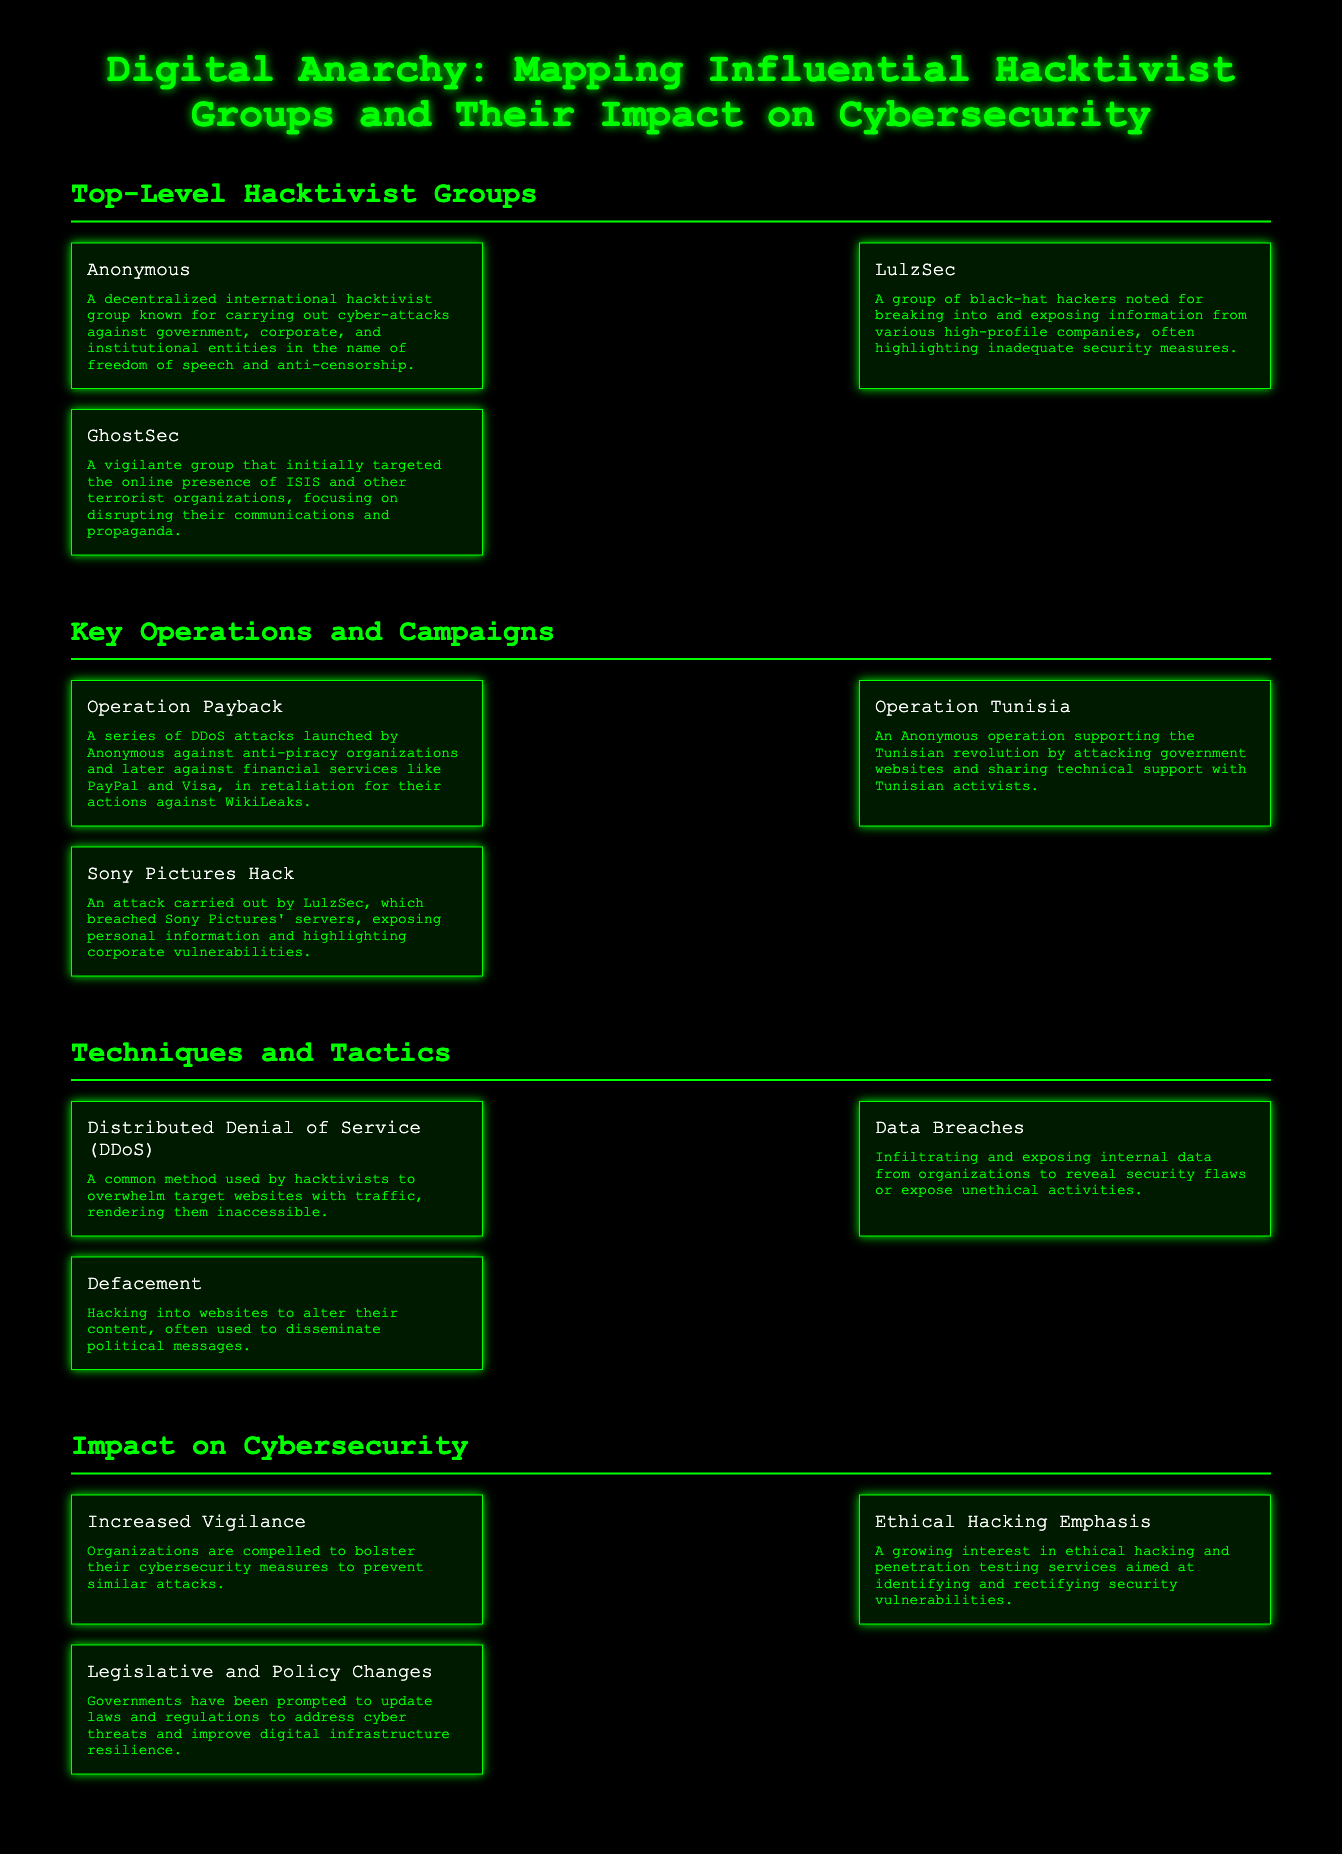what is the name of the decentralized hacktivist group? The document lists "Anonymous" as a decentralized international hacktivist group.
Answer: Anonymous which group is noted for breaking into high-profile companies? "LulzSec" is identified as a group noted for breaking into and exposing information from various high-profile companies.
Answer: LulzSec what operation supported the Tunisian revolution? The operation "Operation Tunisia" is mentioned as supporting the Tunisian revolution.
Answer: Operation Tunisia what technique is used to overwhelm target websites with traffic? The technique described for overwhelming target websites is called Distributed Denial of Service (DDoS).
Answer: DDoS which impact compels organizations to improve security measures? The document states that "Increased Vigilance" is an impact that compels organizations to bolster their cybersecurity measures.
Answer: Increased Vigilance how many top-level hacktivist groups are listed? The document lists a total of three top-level hacktivist groups.
Answer: Three what is the focus of the group GhostSec? GhostSec focuses on disrupting the online presence of terrorist organizations, specifically ISIS.
Answer: ISIS which hacktivist group highlighted corporate vulnerabilities through an attack? The group LulzSec is mentioned for highlighting corporate vulnerabilities through their attacks.
Answer: LulzSec what encourages interest in ethical hacking? The document notes "Ethical Hacking Emphasis" as a growing interest in addressing security vulnerabilities.
Answer: Ethical Hacking Emphasis 